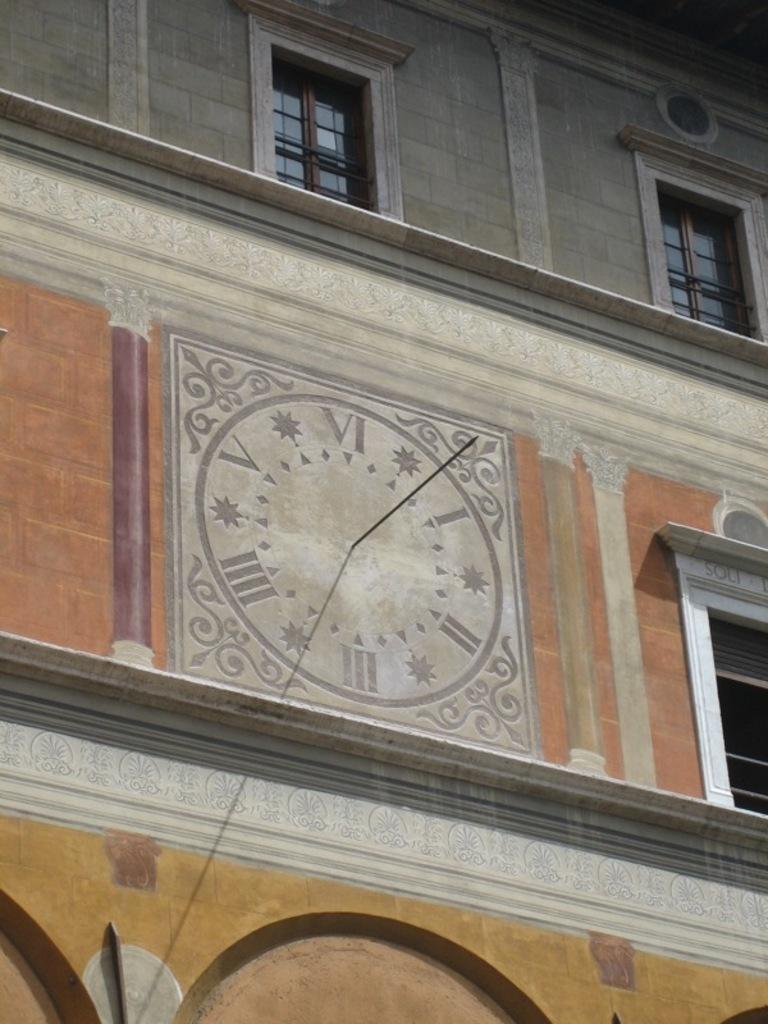What type of structure is in the image? There is a building in the image. What colors are used in the building's design? The building has a grey, orange, yellow, and white color scheme. What design element is present in the center of the building? There is a clock design in the center of the building. What feature is common in most buildings and is present in this one? The building has windows. What type of branch can be seen growing from the building in the image? There is no branch growing from the building in the image. What appliance is being used to cook food in the image? There is no appliance or cooking activity depicted in the image. 